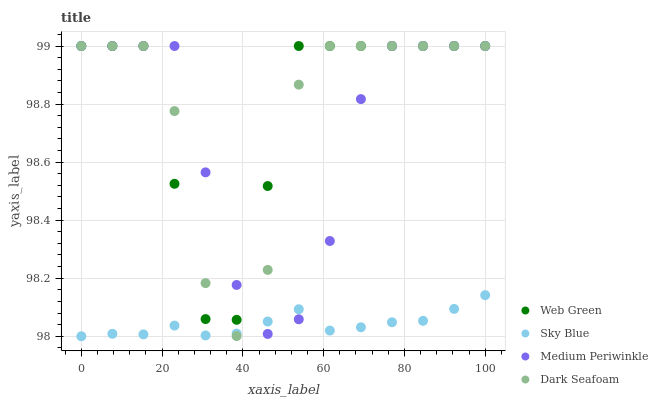Does Sky Blue have the minimum area under the curve?
Answer yes or no. Yes. Does Web Green have the maximum area under the curve?
Answer yes or no. Yes. Does Dark Seafoam have the minimum area under the curve?
Answer yes or no. No. Does Dark Seafoam have the maximum area under the curve?
Answer yes or no. No. Is Sky Blue the smoothest?
Answer yes or no. Yes. Is Dark Seafoam the roughest?
Answer yes or no. Yes. Is Medium Periwinkle the smoothest?
Answer yes or no. No. Is Medium Periwinkle the roughest?
Answer yes or no. No. Does Sky Blue have the lowest value?
Answer yes or no. Yes. Does Dark Seafoam have the lowest value?
Answer yes or no. No. Does Web Green have the highest value?
Answer yes or no. Yes. Is Sky Blue less than Web Green?
Answer yes or no. Yes. Is Web Green greater than Sky Blue?
Answer yes or no. Yes. Does Sky Blue intersect Medium Periwinkle?
Answer yes or no. Yes. Is Sky Blue less than Medium Periwinkle?
Answer yes or no. No. Is Sky Blue greater than Medium Periwinkle?
Answer yes or no. No. Does Sky Blue intersect Web Green?
Answer yes or no. No. 